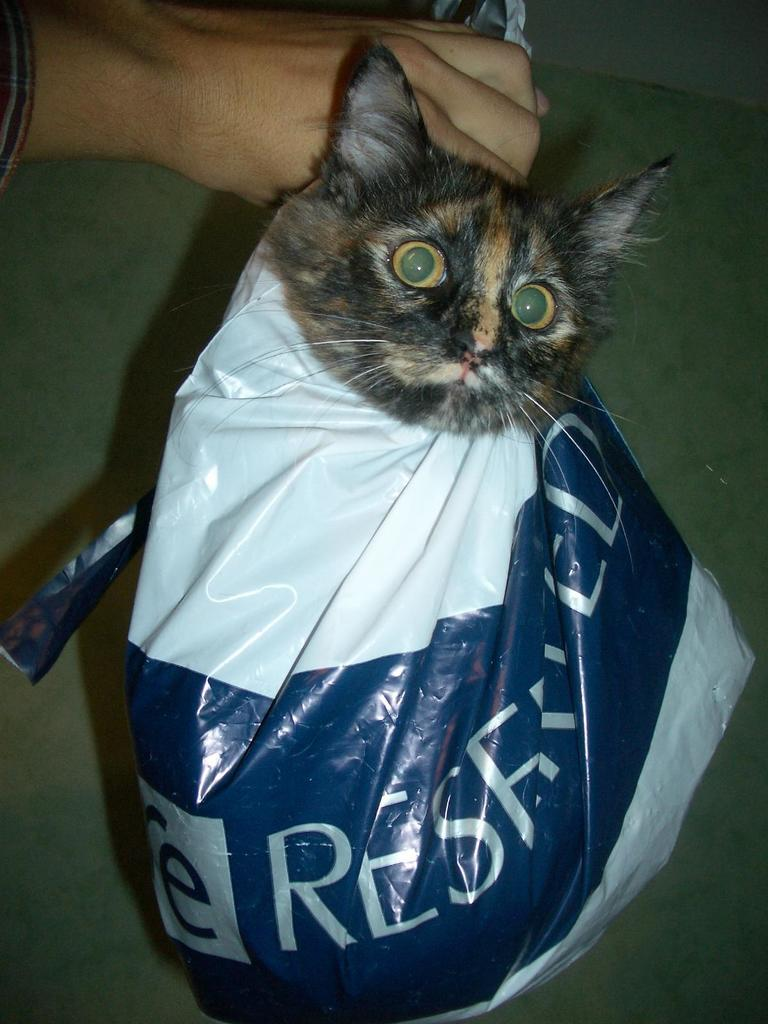What type of animal is in the image? There is a cat in the image. How is the cat contained in the image? The cat is in a plastic cover. What colors can be seen on the cat's fur? The cat has black and brown coloring. Whose hand is visible in the image? A person's hand is visible in the image. What type of hill can be seen in the background of the image? There is no hill visible in the image; it only features a cat in a plastic cover and a person's hand. 